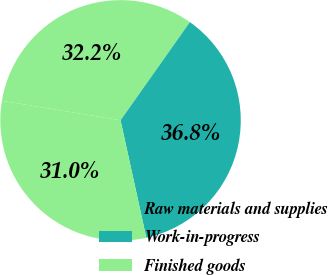Convert chart to OTSL. <chart><loc_0><loc_0><loc_500><loc_500><pie_chart><fcel>Raw materials and supplies<fcel>Work-in-progress<fcel>Finished goods<nl><fcel>32.18%<fcel>36.78%<fcel>31.04%<nl></chart> 